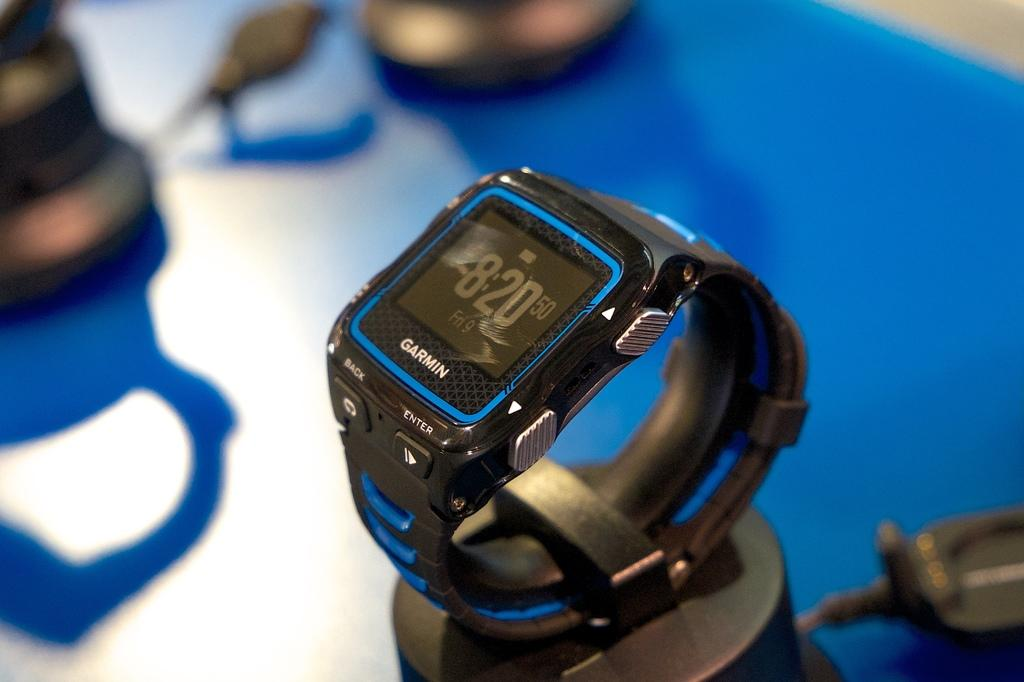<image>
Describe the image concisely. A watch made by the brand Garmin that is blue and black. 